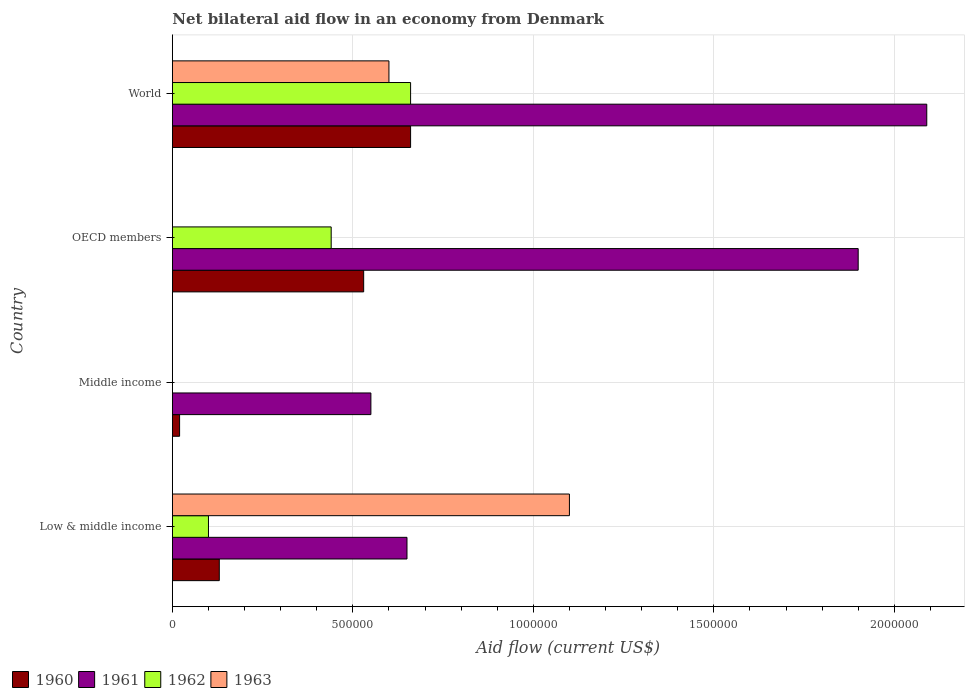How many groups of bars are there?
Give a very brief answer. 4. How many bars are there on the 4th tick from the top?
Provide a short and direct response. 4. How many bars are there on the 2nd tick from the bottom?
Your answer should be very brief. 2. What is the label of the 1st group of bars from the top?
Your answer should be compact. World. In how many cases, is the number of bars for a given country not equal to the number of legend labels?
Provide a succinct answer. 2. What is the net bilateral aid flow in 1961 in Low & middle income?
Provide a short and direct response. 6.50e+05. Across all countries, what is the maximum net bilateral aid flow in 1963?
Offer a terse response. 1.10e+06. Across all countries, what is the minimum net bilateral aid flow in 1963?
Ensure brevity in your answer.  0. What is the total net bilateral aid flow in 1960 in the graph?
Your answer should be compact. 1.34e+06. What is the difference between the net bilateral aid flow in 1960 in Low & middle income and that in World?
Ensure brevity in your answer.  -5.30e+05. What is the average net bilateral aid flow in 1961 per country?
Give a very brief answer. 1.30e+06. In how many countries, is the net bilateral aid flow in 1962 greater than 1500000 US$?
Give a very brief answer. 0. What is the ratio of the net bilateral aid flow in 1962 in Low & middle income to that in World?
Make the answer very short. 0.15. Is the difference between the net bilateral aid flow in 1962 in Low & middle income and World greater than the difference between the net bilateral aid flow in 1963 in Low & middle income and World?
Give a very brief answer. No. What is the difference between the highest and the lowest net bilateral aid flow in 1963?
Provide a short and direct response. 1.10e+06. Is it the case that in every country, the sum of the net bilateral aid flow in 1960 and net bilateral aid flow in 1962 is greater than the net bilateral aid flow in 1963?
Make the answer very short. No. How many bars are there?
Make the answer very short. 13. Are all the bars in the graph horizontal?
Give a very brief answer. Yes. What is the difference between two consecutive major ticks on the X-axis?
Give a very brief answer. 5.00e+05. Does the graph contain grids?
Provide a short and direct response. Yes. What is the title of the graph?
Your answer should be compact. Net bilateral aid flow in an economy from Denmark. Does "2000" appear as one of the legend labels in the graph?
Keep it short and to the point. No. What is the label or title of the X-axis?
Your answer should be compact. Aid flow (current US$). What is the Aid flow (current US$) of 1960 in Low & middle income?
Give a very brief answer. 1.30e+05. What is the Aid flow (current US$) of 1961 in Low & middle income?
Offer a very short reply. 6.50e+05. What is the Aid flow (current US$) in 1962 in Low & middle income?
Keep it short and to the point. 1.00e+05. What is the Aid flow (current US$) of 1963 in Low & middle income?
Give a very brief answer. 1.10e+06. What is the Aid flow (current US$) of 1961 in Middle income?
Offer a terse response. 5.50e+05. What is the Aid flow (current US$) in 1960 in OECD members?
Offer a very short reply. 5.30e+05. What is the Aid flow (current US$) of 1961 in OECD members?
Ensure brevity in your answer.  1.90e+06. What is the Aid flow (current US$) in 1963 in OECD members?
Offer a very short reply. 0. What is the Aid flow (current US$) in 1960 in World?
Provide a short and direct response. 6.60e+05. What is the Aid flow (current US$) in 1961 in World?
Offer a terse response. 2.09e+06. Across all countries, what is the maximum Aid flow (current US$) in 1961?
Keep it short and to the point. 2.09e+06. Across all countries, what is the maximum Aid flow (current US$) of 1963?
Your response must be concise. 1.10e+06. Across all countries, what is the minimum Aid flow (current US$) in 1960?
Make the answer very short. 2.00e+04. Across all countries, what is the minimum Aid flow (current US$) of 1961?
Ensure brevity in your answer.  5.50e+05. Across all countries, what is the minimum Aid flow (current US$) in 1962?
Ensure brevity in your answer.  0. Across all countries, what is the minimum Aid flow (current US$) of 1963?
Provide a succinct answer. 0. What is the total Aid flow (current US$) of 1960 in the graph?
Your answer should be very brief. 1.34e+06. What is the total Aid flow (current US$) of 1961 in the graph?
Make the answer very short. 5.19e+06. What is the total Aid flow (current US$) of 1962 in the graph?
Ensure brevity in your answer.  1.20e+06. What is the total Aid flow (current US$) in 1963 in the graph?
Ensure brevity in your answer.  1.70e+06. What is the difference between the Aid flow (current US$) in 1960 in Low & middle income and that in Middle income?
Keep it short and to the point. 1.10e+05. What is the difference between the Aid flow (current US$) of 1961 in Low & middle income and that in Middle income?
Your answer should be compact. 1.00e+05. What is the difference between the Aid flow (current US$) of 1960 in Low & middle income and that in OECD members?
Offer a very short reply. -4.00e+05. What is the difference between the Aid flow (current US$) of 1961 in Low & middle income and that in OECD members?
Your answer should be compact. -1.25e+06. What is the difference between the Aid flow (current US$) of 1962 in Low & middle income and that in OECD members?
Keep it short and to the point. -3.40e+05. What is the difference between the Aid flow (current US$) of 1960 in Low & middle income and that in World?
Give a very brief answer. -5.30e+05. What is the difference between the Aid flow (current US$) of 1961 in Low & middle income and that in World?
Your response must be concise. -1.44e+06. What is the difference between the Aid flow (current US$) of 1962 in Low & middle income and that in World?
Ensure brevity in your answer.  -5.60e+05. What is the difference between the Aid flow (current US$) of 1963 in Low & middle income and that in World?
Offer a terse response. 5.00e+05. What is the difference between the Aid flow (current US$) in 1960 in Middle income and that in OECD members?
Provide a succinct answer. -5.10e+05. What is the difference between the Aid flow (current US$) of 1961 in Middle income and that in OECD members?
Provide a short and direct response. -1.35e+06. What is the difference between the Aid flow (current US$) in 1960 in Middle income and that in World?
Offer a terse response. -6.40e+05. What is the difference between the Aid flow (current US$) of 1961 in Middle income and that in World?
Your answer should be compact. -1.54e+06. What is the difference between the Aid flow (current US$) of 1961 in OECD members and that in World?
Offer a terse response. -1.90e+05. What is the difference between the Aid flow (current US$) of 1960 in Low & middle income and the Aid flow (current US$) of 1961 in Middle income?
Give a very brief answer. -4.20e+05. What is the difference between the Aid flow (current US$) in 1960 in Low & middle income and the Aid flow (current US$) in 1961 in OECD members?
Your response must be concise. -1.77e+06. What is the difference between the Aid flow (current US$) in 1960 in Low & middle income and the Aid flow (current US$) in 1962 in OECD members?
Keep it short and to the point. -3.10e+05. What is the difference between the Aid flow (current US$) of 1961 in Low & middle income and the Aid flow (current US$) of 1962 in OECD members?
Offer a very short reply. 2.10e+05. What is the difference between the Aid flow (current US$) of 1960 in Low & middle income and the Aid flow (current US$) of 1961 in World?
Offer a very short reply. -1.96e+06. What is the difference between the Aid flow (current US$) of 1960 in Low & middle income and the Aid flow (current US$) of 1962 in World?
Offer a terse response. -5.30e+05. What is the difference between the Aid flow (current US$) in 1960 in Low & middle income and the Aid flow (current US$) in 1963 in World?
Offer a terse response. -4.70e+05. What is the difference between the Aid flow (current US$) of 1962 in Low & middle income and the Aid flow (current US$) of 1963 in World?
Your answer should be compact. -5.00e+05. What is the difference between the Aid flow (current US$) of 1960 in Middle income and the Aid flow (current US$) of 1961 in OECD members?
Give a very brief answer. -1.88e+06. What is the difference between the Aid flow (current US$) in 1960 in Middle income and the Aid flow (current US$) in 1962 in OECD members?
Provide a short and direct response. -4.20e+05. What is the difference between the Aid flow (current US$) in 1961 in Middle income and the Aid flow (current US$) in 1962 in OECD members?
Your answer should be very brief. 1.10e+05. What is the difference between the Aid flow (current US$) in 1960 in Middle income and the Aid flow (current US$) in 1961 in World?
Your response must be concise. -2.07e+06. What is the difference between the Aid flow (current US$) of 1960 in Middle income and the Aid flow (current US$) of 1962 in World?
Your response must be concise. -6.40e+05. What is the difference between the Aid flow (current US$) of 1960 in Middle income and the Aid flow (current US$) of 1963 in World?
Give a very brief answer. -5.80e+05. What is the difference between the Aid flow (current US$) in 1961 in Middle income and the Aid flow (current US$) in 1962 in World?
Give a very brief answer. -1.10e+05. What is the difference between the Aid flow (current US$) in 1960 in OECD members and the Aid flow (current US$) in 1961 in World?
Keep it short and to the point. -1.56e+06. What is the difference between the Aid flow (current US$) of 1960 in OECD members and the Aid flow (current US$) of 1963 in World?
Give a very brief answer. -7.00e+04. What is the difference between the Aid flow (current US$) in 1961 in OECD members and the Aid flow (current US$) in 1962 in World?
Your answer should be compact. 1.24e+06. What is the difference between the Aid flow (current US$) in 1961 in OECD members and the Aid flow (current US$) in 1963 in World?
Give a very brief answer. 1.30e+06. What is the difference between the Aid flow (current US$) in 1962 in OECD members and the Aid flow (current US$) in 1963 in World?
Ensure brevity in your answer.  -1.60e+05. What is the average Aid flow (current US$) in 1960 per country?
Make the answer very short. 3.35e+05. What is the average Aid flow (current US$) of 1961 per country?
Ensure brevity in your answer.  1.30e+06. What is the average Aid flow (current US$) of 1962 per country?
Your answer should be compact. 3.00e+05. What is the average Aid flow (current US$) in 1963 per country?
Provide a succinct answer. 4.25e+05. What is the difference between the Aid flow (current US$) in 1960 and Aid flow (current US$) in 1961 in Low & middle income?
Ensure brevity in your answer.  -5.20e+05. What is the difference between the Aid flow (current US$) of 1960 and Aid flow (current US$) of 1962 in Low & middle income?
Your answer should be compact. 3.00e+04. What is the difference between the Aid flow (current US$) in 1960 and Aid flow (current US$) in 1963 in Low & middle income?
Your answer should be compact. -9.70e+05. What is the difference between the Aid flow (current US$) of 1961 and Aid flow (current US$) of 1963 in Low & middle income?
Provide a succinct answer. -4.50e+05. What is the difference between the Aid flow (current US$) in 1962 and Aid flow (current US$) in 1963 in Low & middle income?
Your response must be concise. -1.00e+06. What is the difference between the Aid flow (current US$) of 1960 and Aid flow (current US$) of 1961 in Middle income?
Ensure brevity in your answer.  -5.30e+05. What is the difference between the Aid flow (current US$) in 1960 and Aid flow (current US$) in 1961 in OECD members?
Give a very brief answer. -1.37e+06. What is the difference between the Aid flow (current US$) of 1961 and Aid flow (current US$) of 1962 in OECD members?
Keep it short and to the point. 1.46e+06. What is the difference between the Aid flow (current US$) in 1960 and Aid flow (current US$) in 1961 in World?
Give a very brief answer. -1.43e+06. What is the difference between the Aid flow (current US$) in 1961 and Aid flow (current US$) in 1962 in World?
Offer a very short reply. 1.43e+06. What is the difference between the Aid flow (current US$) of 1961 and Aid flow (current US$) of 1963 in World?
Offer a very short reply. 1.49e+06. What is the difference between the Aid flow (current US$) of 1962 and Aid flow (current US$) of 1963 in World?
Your response must be concise. 6.00e+04. What is the ratio of the Aid flow (current US$) of 1960 in Low & middle income to that in Middle income?
Offer a very short reply. 6.5. What is the ratio of the Aid flow (current US$) of 1961 in Low & middle income to that in Middle income?
Make the answer very short. 1.18. What is the ratio of the Aid flow (current US$) in 1960 in Low & middle income to that in OECD members?
Offer a terse response. 0.25. What is the ratio of the Aid flow (current US$) of 1961 in Low & middle income to that in OECD members?
Ensure brevity in your answer.  0.34. What is the ratio of the Aid flow (current US$) of 1962 in Low & middle income to that in OECD members?
Make the answer very short. 0.23. What is the ratio of the Aid flow (current US$) in 1960 in Low & middle income to that in World?
Offer a very short reply. 0.2. What is the ratio of the Aid flow (current US$) in 1961 in Low & middle income to that in World?
Provide a succinct answer. 0.31. What is the ratio of the Aid flow (current US$) of 1962 in Low & middle income to that in World?
Your answer should be very brief. 0.15. What is the ratio of the Aid flow (current US$) in 1963 in Low & middle income to that in World?
Offer a terse response. 1.83. What is the ratio of the Aid flow (current US$) of 1960 in Middle income to that in OECD members?
Ensure brevity in your answer.  0.04. What is the ratio of the Aid flow (current US$) in 1961 in Middle income to that in OECD members?
Your response must be concise. 0.29. What is the ratio of the Aid flow (current US$) in 1960 in Middle income to that in World?
Give a very brief answer. 0.03. What is the ratio of the Aid flow (current US$) in 1961 in Middle income to that in World?
Offer a very short reply. 0.26. What is the ratio of the Aid flow (current US$) of 1960 in OECD members to that in World?
Ensure brevity in your answer.  0.8. What is the ratio of the Aid flow (current US$) in 1962 in OECD members to that in World?
Give a very brief answer. 0.67. What is the difference between the highest and the second highest Aid flow (current US$) of 1961?
Provide a short and direct response. 1.90e+05. What is the difference between the highest and the lowest Aid flow (current US$) of 1960?
Provide a short and direct response. 6.40e+05. What is the difference between the highest and the lowest Aid flow (current US$) of 1961?
Ensure brevity in your answer.  1.54e+06. What is the difference between the highest and the lowest Aid flow (current US$) in 1962?
Make the answer very short. 6.60e+05. What is the difference between the highest and the lowest Aid flow (current US$) of 1963?
Your answer should be compact. 1.10e+06. 